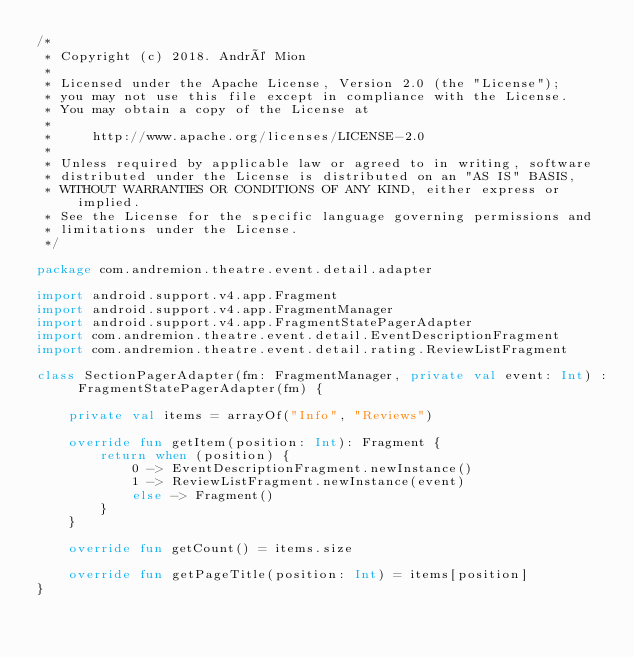Convert code to text. <code><loc_0><loc_0><loc_500><loc_500><_Kotlin_>/*
 * Copyright (c) 2018. André Mion
 *
 * Licensed under the Apache License, Version 2.0 (the "License");
 * you may not use this file except in compliance with the License.
 * You may obtain a copy of the License at
 *
 *     http://www.apache.org/licenses/LICENSE-2.0
 *
 * Unless required by applicable law or agreed to in writing, software
 * distributed under the License is distributed on an "AS IS" BASIS,
 * WITHOUT WARRANTIES OR CONDITIONS OF ANY KIND, either express or implied.
 * See the License for the specific language governing permissions and
 * limitations under the License.
 */

package com.andremion.theatre.event.detail.adapter

import android.support.v4.app.Fragment
import android.support.v4.app.FragmentManager
import android.support.v4.app.FragmentStatePagerAdapter
import com.andremion.theatre.event.detail.EventDescriptionFragment
import com.andremion.theatre.event.detail.rating.ReviewListFragment

class SectionPagerAdapter(fm: FragmentManager, private val event: Int) : FragmentStatePagerAdapter(fm) {

    private val items = arrayOf("Info", "Reviews")

    override fun getItem(position: Int): Fragment {
        return when (position) {
            0 -> EventDescriptionFragment.newInstance()
            1 -> ReviewListFragment.newInstance(event)
            else -> Fragment()
        }
    }

    override fun getCount() = items.size

    override fun getPageTitle(position: Int) = items[position]
}</code> 